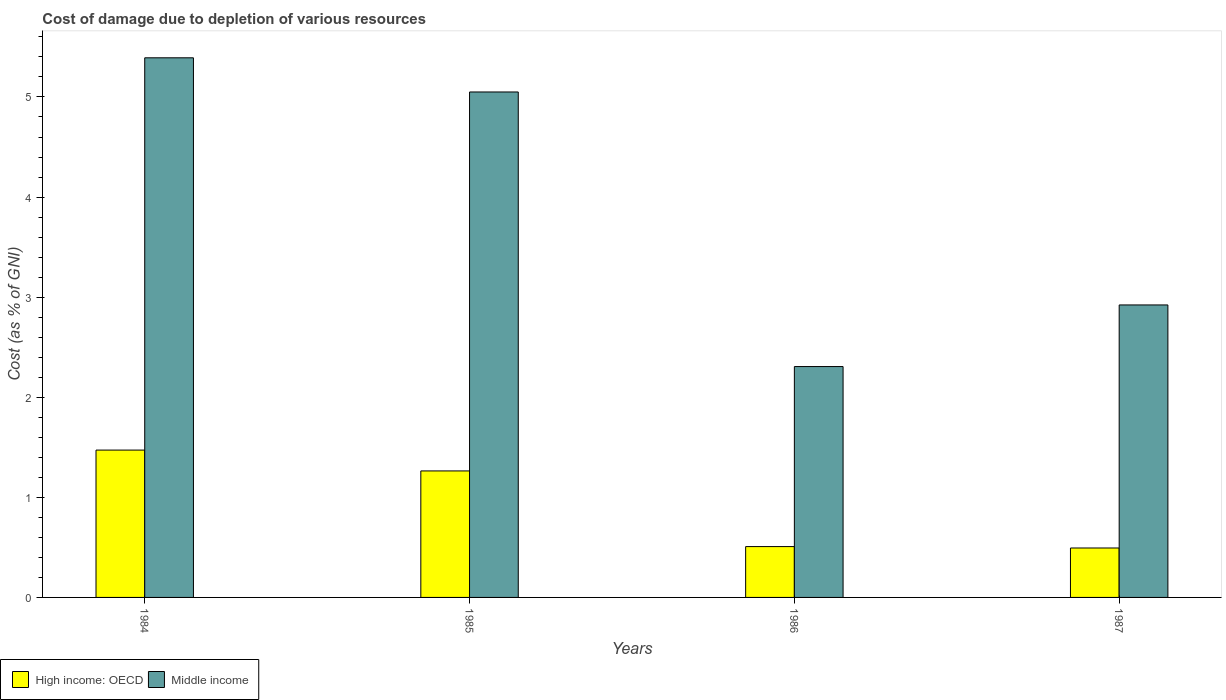How many different coloured bars are there?
Give a very brief answer. 2. How many groups of bars are there?
Your answer should be compact. 4. Are the number of bars per tick equal to the number of legend labels?
Provide a succinct answer. Yes. How many bars are there on the 1st tick from the left?
Your answer should be very brief. 2. How many bars are there on the 1st tick from the right?
Your answer should be compact. 2. What is the cost of damage caused due to the depletion of various resources in High income: OECD in 1987?
Provide a short and direct response. 0.49. Across all years, what is the maximum cost of damage caused due to the depletion of various resources in High income: OECD?
Your response must be concise. 1.47. Across all years, what is the minimum cost of damage caused due to the depletion of various resources in Middle income?
Give a very brief answer. 2.31. In which year was the cost of damage caused due to the depletion of various resources in Middle income maximum?
Your answer should be very brief. 1984. What is the total cost of damage caused due to the depletion of various resources in High income: OECD in the graph?
Your answer should be very brief. 3.74. What is the difference between the cost of damage caused due to the depletion of various resources in High income: OECD in 1985 and that in 1986?
Provide a short and direct response. 0.76. What is the difference between the cost of damage caused due to the depletion of various resources in High income: OECD in 1985 and the cost of damage caused due to the depletion of various resources in Middle income in 1984?
Give a very brief answer. -4.13. What is the average cost of damage caused due to the depletion of various resources in Middle income per year?
Your answer should be very brief. 3.92. In the year 1984, what is the difference between the cost of damage caused due to the depletion of various resources in Middle income and cost of damage caused due to the depletion of various resources in High income: OECD?
Your answer should be compact. 3.92. In how many years, is the cost of damage caused due to the depletion of various resources in High income: OECD greater than 2.4 %?
Your response must be concise. 0. What is the ratio of the cost of damage caused due to the depletion of various resources in Middle income in 1984 to that in 1986?
Provide a short and direct response. 2.34. Is the cost of damage caused due to the depletion of various resources in Middle income in 1986 less than that in 1987?
Keep it short and to the point. Yes. What is the difference between the highest and the second highest cost of damage caused due to the depletion of various resources in Middle income?
Keep it short and to the point. 0.34. What is the difference between the highest and the lowest cost of damage caused due to the depletion of various resources in Middle income?
Your answer should be very brief. 3.08. In how many years, is the cost of damage caused due to the depletion of various resources in Middle income greater than the average cost of damage caused due to the depletion of various resources in Middle income taken over all years?
Your response must be concise. 2. Is the sum of the cost of damage caused due to the depletion of various resources in High income: OECD in 1985 and 1986 greater than the maximum cost of damage caused due to the depletion of various resources in Middle income across all years?
Your response must be concise. No. What does the 1st bar from the left in 1987 represents?
Your answer should be very brief. High income: OECD. How many bars are there?
Your response must be concise. 8. Are all the bars in the graph horizontal?
Make the answer very short. No. What is the difference between two consecutive major ticks on the Y-axis?
Ensure brevity in your answer.  1. How many legend labels are there?
Ensure brevity in your answer.  2. How are the legend labels stacked?
Give a very brief answer. Horizontal. What is the title of the graph?
Provide a short and direct response. Cost of damage due to depletion of various resources. What is the label or title of the X-axis?
Give a very brief answer. Years. What is the label or title of the Y-axis?
Offer a very short reply. Cost (as % of GNI). What is the Cost (as % of GNI) of High income: OECD in 1984?
Offer a very short reply. 1.47. What is the Cost (as % of GNI) of Middle income in 1984?
Provide a short and direct response. 5.39. What is the Cost (as % of GNI) in High income: OECD in 1985?
Your answer should be compact. 1.26. What is the Cost (as % of GNI) in Middle income in 1985?
Keep it short and to the point. 5.05. What is the Cost (as % of GNI) in High income: OECD in 1986?
Keep it short and to the point. 0.51. What is the Cost (as % of GNI) in Middle income in 1986?
Your answer should be very brief. 2.31. What is the Cost (as % of GNI) of High income: OECD in 1987?
Provide a succinct answer. 0.49. What is the Cost (as % of GNI) in Middle income in 1987?
Make the answer very short. 2.92. Across all years, what is the maximum Cost (as % of GNI) of High income: OECD?
Your answer should be compact. 1.47. Across all years, what is the maximum Cost (as % of GNI) of Middle income?
Your answer should be very brief. 5.39. Across all years, what is the minimum Cost (as % of GNI) of High income: OECD?
Provide a succinct answer. 0.49. Across all years, what is the minimum Cost (as % of GNI) in Middle income?
Keep it short and to the point. 2.31. What is the total Cost (as % of GNI) of High income: OECD in the graph?
Your response must be concise. 3.74. What is the total Cost (as % of GNI) of Middle income in the graph?
Make the answer very short. 15.67. What is the difference between the Cost (as % of GNI) of High income: OECD in 1984 and that in 1985?
Ensure brevity in your answer.  0.21. What is the difference between the Cost (as % of GNI) of Middle income in 1984 and that in 1985?
Offer a terse response. 0.34. What is the difference between the Cost (as % of GNI) in High income: OECD in 1984 and that in 1986?
Offer a terse response. 0.96. What is the difference between the Cost (as % of GNI) in Middle income in 1984 and that in 1986?
Ensure brevity in your answer.  3.08. What is the difference between the Cost (as % of GNI) of High income: OECD in 1984 and that in 1987?
Your response must be concise. 0.98. What is the difference between the Cost (as % of GNI) of Middle income in 1984 and that in 1987?
Provide a succinct answer. 2.47. What is the difference between the Cost (as % of GNI) in High income: OECD in 1985 and that in 1986?
Offer a terse response. 0.76. What is the difference between the Cost (as % of GNI) in Middle income in 1985 and that in 1986?
Your answer should be very brief. 2.74. What is the difference between the Cost (as % of GNI) of High income: OECD in 1985 and that in 1987?
Your answer should be compact. 0.77. What is the difference between the Cost (as % of GNI) in Middle income in 1985 and that in 1987?
Provide a short and direct response. 2.13. What is the difference between the Cost (as % of GNI) of High income: OECD in 1986 and that in 1987?
Provide a succinct answer. 0.01. What is the difference between the Cost (as % of GNI) of Middle income in 1986 and that in 1987?
Ensure brevity in your answer.  -0.62. What is the difference between the Cost (as % of GNI) in High income: OECD in 1984 and the Cost (as % of GNI) in Middle income in 1985?
Your answer should be very brief. -3.58. What is the difference between the Cost (as % of GNI) of High income: OECD in 1984 and the Cost (as % of GNI) of Middle income in 1986?
Your answer should be very brief. -0.83. What is the difference between the Cost (as % of GNI) in High income: OECD in 1984 and the Cost (as % of GNI) in Middle income in 1987?
Your answer should be very brief. -1.45. What is the difference between the Cost (as % of GNI) in High income: OECD in 1985 and the Cost (as % of GNI) in Middle income in 1986?
Keep it short and to the point. -1.04. What is the difference between the Cost (as % of GNI) of High income: OECD in 1985 and the Cost (as % of GNI) of Middle income in 1987?
Give a very brief answer. -1.66. What is the difference between the Cost (as % of GNI) of High income: OECD in 1986 and the Cost (as % of GNI) of Middle income in 1987?
Ensure brevity in your answer.  -2.41. What is the average Cost (as % of GNI) of High income: OECD per year?
Your response must be concise. 0.93. What is the average Cost (as % of GNI) of Middle income per year?
Make the answer very short. 3.92. In the year 1984, what is the difference between the Cost (as % of GNI) in High income: OECD and Cost (as % of GNI) in Middle income?
Ensure brevity in your answer.  -3.92. In the year 1985, what is the difference between the Cost (as % of GNI) in High income: OECD and Cost (as % of GNI) in Middle income?
Your answer should be very brief. -3.79. In the year 1986, what is the difference between the Cost (as % of GNI) of High income: OECD and Cost (as % of GNI) of Middle income?
Offer a very short reply. -1.8. In the year 1987, what is the difference between the Cost (as % of GNI) in High income: OECD and Cost (as % of GNI) in Middle income?
Your response must be concise. -2.43. What is the ratio of the Cost (as % of GNI) of High income: OECD in 1984 to that in 1985?
Your response must be concise. 1.16. What is the ratio of the Cost (as % of GNI) of Middle income in 1984 to that in 1985?
Your response must be concise. 1.07. What is the ratio of the Cost (as % of GNI) of High income: OECD in 1984 to that in 1986?
Keep it short and to the point. 2.9. What is the ratio of the Cost (as % of GNI) in Middle income in 1984 to that in 1986?
Ensure brevity in your answer.  2.34. What is the ratio of the Cost (as % of GNI) of High income: OECD in 1984 to that in 1987?
Provide a short and direct response. 2.98. What is the ratio of the Cost (as % of GNI) of Middle income in 1984 to that in 1987?
Give a very brief answer. 1.84. What is the ratio of the Cost (as % of GNI) of High income: OECD in 1985 to that in 1986?
Your response must be concise. 2.49. What is the ratio of the Cost (as % of GNI) of Middle income in 1985 to that in 1986?
Provide a short and direct response. 2.19. What is the ratio of the Cost (as % of GNI) in High income: OECD in 1985 to that in 1987?
Your answer should be compact. 2.56. What is the ratio of the Cost (as % of GNI) of Middle income in 1985 to that in 1987?
Offer a terse response. 1.73. What is the ratio of the Cost (as % of GNI) of High income: OECD in 1986 to that in 1987?
Give a very brief answer. 1.03. What is the ratio of the Cost (as % of GNI) in Middle income in 1986 to that in 1987?
Offer a terse response. 0.79. What is the difference between the highest and the second highest Cost (as % of GNI) of High income: OECD?
Give a very brief answer. 0.21. What is the difference between the highest and the second highest Cost (as % of GNI) in Middle income?
Keep it short and to the point. 0.34. What is the difference between the highest and the lowest Cost (as % of GNI) of High income: OECD?
Make the answer very short. 0.98. What is the difference between the highest and the lowest Cost (as % of GNI) in Middle income?
Ensure brevity in your answer.  3.08. 